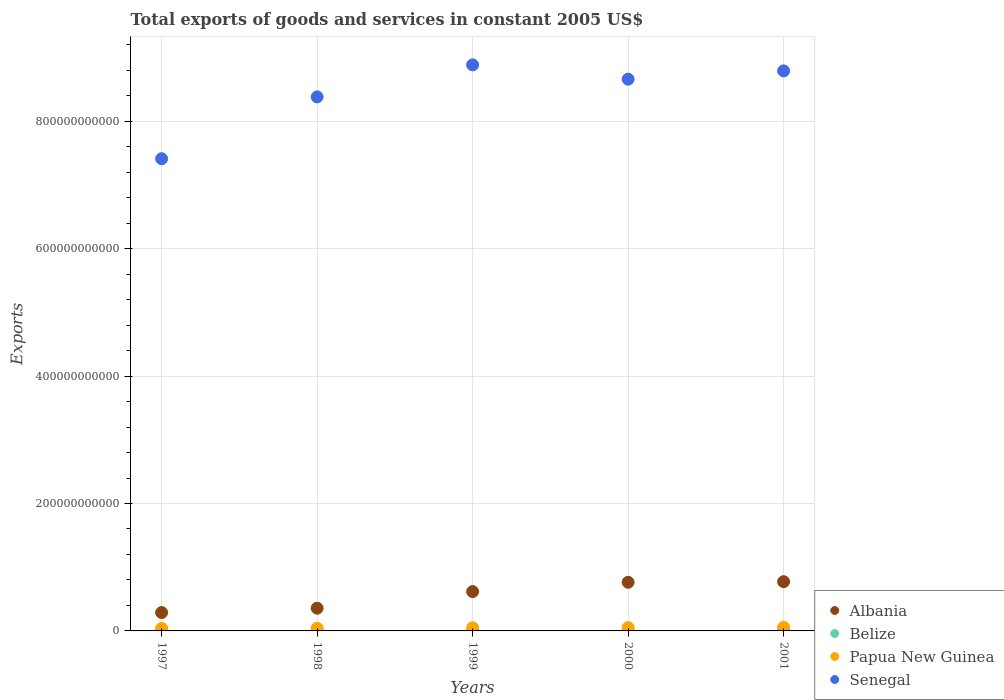What is the total exports of goods and services in Albania in 2000?
Offer a very short reply. 7.63e+1. Across all years, what is the maximum total exports of goods and services in Senegal?
Provide a short and direct response. 8.89e+11. Across all years, what is the minimum total exports of goods and services in Albania?
Ensure brevity in your answer.  2.88e+1. What is the total total exports of goods and services in Belize in the graph?
Your answer should be very brief. 4.02e+09. What is the difference between the total exports of goods and services in Belize in 1997 and that in 2001?
Ensure brevity in your answer.  -2.42e+08. What is the difference between the total exports of goods and services in Senegal in 1997 and the total exports of goods and services in Papua New Guinea in 1999?
Your response must be concise. 7.36e+11. What is the average total exports of goods and services in Belize per year?
Keep it short and to the point. 8.03e+08. In the year 2001, what is the difference between the total exports of goods and services in Papua New Guinea and total exports of goods and services in Belize?
Offer a very short reply. 4.85e+09. What is the ratio of the total exports of goods and services in Senegal in 1997 to that in 1999?
Provide a succinct answer. 0.83. Is the total exports of goods and services in Albania in 1999 less than that in 2000?
Give a very brief answer. Yes. What is the difference between the highest and the second highest total exports of goods and services in Albania?
Your response must be concise. 9.52e+08. What is the difference between the highest and the lowest total exports of goods and services in Senegal?
Provide a short and direct response. 1.47e+11. Is it the case that in every year, the sum of the total exports of goods and services in Albania and total exports of goods and services in Senegal  is greater than the total exports of goods and services in Belize?
Keep it short and to the point. Yes. Does the total exports of goods and services in Belize monotonically increase over the years?
Your answer should be compact. Yes. Is the total exports of goods and services in Belize strictly less than the total exports of goods and services in Senegal over the years?
Provide a succinct answer. Yes. How many dotlines are there?
Ensure brevity in your answer.  4. What is the difference between two consecutive major ticks on the Y-axis?
Make the answer very short. 2.00e+11. Where does the legend appear in the graph?
Your answer should be very brief. Bottom right. What is the title of the graph?
Make the answer very short. Total exports of goods and services in constant 2005 US$. Does "Mexico" appear as one of the legend labels in the graph?
Your answer should be compact. No. What is the label or title of the Y-axis?
Your answer should be very brief. Exports. What is the Exports of Albania in 1997?
Offer a very short reply. 2.88e+1. What is the Exports of Belize in 1997?
Offer a very short reply. 6.83e+08. What is the Exports in Papua New Guinea in 1997?
Your response must be concise. 3.99e+09. What is the Exports in Senegal in 1997?
Provide a succinct answer. 7.41e+11. What is the Exports of Albania in 1998?
Ensure brevity in your answer.  3.57e+1. What is the Exports of Belize in 1998?
Provide a succinct answer. 7.17e+08. What is the Exports of Papua New Guinea in 1998?
Ensure brevity in your answer.  4.22e+09. What is the Exports in Senegal in 1998?
Keep it short and to the point. 8.38e+11. What is the Exports in Albania in 1999?
Offer a very short reply. 6.18e+1. What is the Exports of Belize in 1999?
Your response must be concise. 8.11e+08. What is the Exports of Papua New Guinea in 1999?
Provide a succinct answer. 4.88e+09. What is the Exports in Senegal in 1999?
Offer a terse response. 8.89e+11. What is the Exports of Albania in 2000?
Give a very brief answer. 7.63e+1. What is the Exports of Belize in 2000?
Provide a succinct answer. 8.82e+08. What is the Exports of Papua New Guinea in 2000?
Provide a short and direct response. 5.23e+09. What is the Exports of Senegal in 2000?
Keep it short and to the point. 8.66e+11. What is the Exports in Albania in 2001?
Your response must be concise. 7.73e+1. What is the Exports of Belize in 2001?
Offer a very short reply. 9.25e+08. What is the Exports in Papua New Guinea in 2001?
Offer a very short reply. 5.78e+09. What is the Exports of Senegal in 2001?
Your response must be concise. 8.79e+11. Across all years, what is the maximum Exports in Albania?
Your answer should be compact. 7.73e+1. Across all years, what is the maximum Exports of Belize?
Ensure brevity in your answer.  9.25e+08. Across all years, what is the maximum Exports of Papua New Guinea?
Make the answer very short. 5.78e+09. Across all years, what is the maximum Exports in Senegal?
Your answer should be compact. 8.89e+11. Across all years, what is the minimum Exports of Albania?
Offer a very short reply. 2.88e+1. Across all years, what is the minimum Exports in Belize?
Provide a succinct answer. 6.83e+08. Across all years, what is the minimum Exports in Papua New Guinea?
Offer a very short reply. 3.99e+09. Across all years, what is the minimum Exports of Senegal?
Offer a very short reply. 7.41e+11. What is the total Exports of Albania in the graph?
Offer a terse response. 2.80e+11. What is the total Exports in Belize in the graph?
Make the answer very short. 4.02e+09. What is the total Exports of Papua New Guinea in the graph?
Keep it short and to the point. 2.41e+1. What is the total Exports of Senegal in the graph?
Provide a short and direct response. 4.21e+12. What is the difference between the Exports of Albania in 1997 and that in 1998?
Your answer should be compact. -6.86e+09. What is the difference between the Exports of Belize in 1997 and that in 1998?
Make the answer very short. -3.49e+07. What is the difference between the Exports of Papua New Guinea in 1997 and that in 1998?
Give a very brief answer. -2.25e+08. What is the difference between the Exports of Senegal in 1997 and that in 1998?
Offer a terse response. -9.71e+1. What is the difference between the Exports in Albania in 1997 and that in 1999?
Provide a short and direct response. -3.29e+1. What is the difference between the Exports in Belize in 1997 and that in 1999?
Give a very brief answer. -1.28e+08. What is the difference between the Exports of Papua New Guinea in 1997 and that in 1999?
Offer a terse response. -8.91e+08. What is the difference between the Exports of Senegal in 1997 and that in 1999?
Give a very brief answer. -1.47e+11. What is the difference between the Exports in Albania in 1997 and that in 2000?
Offer a very short reply. -4.75e+1. What is the difference between the Exports of Belize in 1997 and that in 2000?
Provide a succinct answer. -1.99e+08. What is the difference between the Exports in Papua New Guinea in 1997 and that in 2000?
Ensure brevity in your answer.  -1.24e+09. What is the difference between the Exports in Senegal in 1997 and that in 2000?
Ensure brevity in your answer.  -1.25e+11. What is the difference between the Exports of Albania in 1997 and that in 2001?
Your answer should be compact. -4.85e+1. What is the difference between the Exports in Belize in 1997 and that in 2001?
Offer a terse response. -2.42e+08. What is the difference between the Exports in Papua New Guinea in 1997 and that in 2001?
Give a very brief answer. -1.78e+09. What is the difference between the Exports of Senegal in 1997 and that in 2001?
Provide a short and direct response. -1.38e+11. What is the difference between the Exports of Albania in 1998 and that in 1999?
Keep it short and to the point. -2.61e+1. What is the difference between the Exports of Belize in 1998 and that in 1999?
Offer a terse response. -9.31e+07. What is the difference between the Exports of Papua New Guinea in 1998 and that in 1999?
Give a very brief answer. -6.66e+08. What is the difference between the Exports of Senegal in 1998 and that in 1999?
Give a very brief answer. -5.03e+1. What is the difference between the Exports in Albania in 1998 and that in 2000?
Your response must be concise. -4.07e+1. What is the difference between the Exports of Belize in 1998 and that in 2000?
Make the answer very short. -1.64e+08. What is the difference between the Exports in Papua New Guinea in 1998 and that in 2000?
Make the answer very short. -1.01e+09. What is the difference between the Exports in Senegal in 1998 and that in 2000?
Provide a short and direct response. -2.78e+1. What is the difference between the Exports of Albania in 1998 and that in 2001?
Make the answer very short. -4.16e+1. What is the difference between the Exports in Belize in 1998 and that in 2001?
Keep it short and to the point. -2.07e+08. What is the difference between the Exports of Papua New Guinea in 1998 and that in 2001?
Your response must be concise. -1.56e+09. What is the difference between the Exports in Senegal in 1998 and that in 2001?
Offer a terse response. -4.08e+1. What is the difference between the Exports in Albania in 1999 and that in 2000?
Give a very brief answer. -1.46e+1. What is the difference between the Exports of Belize in 1999 and that in 2000?
Ensure brevity in your answer.  -7.09e+07. What is the difference between the Exports in Papua New Guinea in 1999 and that in 2000?
Offer a terse response. -3.46e+08. What is the difference between the Exports in Senegal in 1999 and that in 2000?
Make the answer very short. 2.25e+1. What is the difference between the Exports of Albania in 1999 and that in 2001?
Offer a terse response. -1.55e+1. What is the difference between the Exports in Belize in 1999 and that in 2001?
Give a very brief answer. -1.14e+08. What is the difference between the Exports in Papua New Guinea in 1999 and that in 2001?
Give a very brief answer. -8.92e+08. What is the difference between the Exports in Senegal in 1999 and that in 2001?
Give a very brief answer. 9.46e+09. What is the difference between the Exports of Albania in 2000 and that in 2001?
Make the answer very short. -9.52e+08. What is the difference between the Exports in Belize in 2000 and that in 2001?
Your answer should be compact. -4.34e+07. What is the difference between the Exports in Papua New Guinea in 2000 and that in 2001?
Provide a succinct answer. -5.46e+08. What is the difference between the Exports of Senegal in 2000 and that in 2001?
Make the answer very short. -1.30e+1. What is the difference between the Exports in Albania in 1997 and the Exports in Belize in 1998?
Provide a succinct answer. 2.81e+1. What is the difference between the Exports of Albania in 1997 and the Exports of Papua New Guinea in 1998?
Give a very brief answer. 2.46e+1. What is the difference between the Exports in Albania in 1997 and the Exports in Senegal in 1998?
Give a very brief answer. -8.10e+11. What is the difference between the Exports in Belize in 1997 and the Exports in Papua New Guinea in 1998?
Your answer should be very brief. -3.53e+09. What is the difference between the Exports in Belize in 1997 and the Exports in Senegal in 1998?
Provide a short and direct response. -8.38e+11. What is the difference between the Exports in Papua New Guinea in 1997 and the Exports in Senegal in 1998?
Your answer should be very brief. -8.34e+11. What is the difference between the Exports in Albania in 1997 and the Exports in Belize in 1999?
Ensure brevity in your answer.  2.80e+1. What is the difference between the Exports in Albania in 1997 and the Exports in Papua New Guinea in 1999?
Your answer should be compact. 2.39e+1. What is the difference between the Exports in Albania in 1997 and the Exports in Senegal in 1999?
Your answer should be compact. -8.60e+11. What is the difference between the Exports in Belize in 1997 and the Exports in Papua New Guinea in 1999?
Your answer should be very brief. -4.20e+09. What is the difference between the Exports of Belize in 1997 and the Exports of Senegal in 1999?
Offer a very short reply. -8.88e+11. What is the difference between the Exports of Papua New Guinea in 1997 and the Exports of Senegal in 1999?
Your answer should be very brief. -8.85e+11. What is the difference between the Exports in Albania in 1997 and the Exports in Belize in 2000?
Provide a succinct answer. 2.79e+1. What is the difference between the Exports in Albania in 1997 and the Exports in Papua New Guinea in 2000?
Your response must be concise. 2.36e+1. What is the difference between the Exports of Albania in 1997 and the Exports of Senegal in 2000?
Offer a very short reply. -8.37e+11. What is the difference between the Exports of Belize in 1997 and the Exports of Papua New Guinea in 2000?
Provide a succinct answer. -4.55e+09. What is the difference between the Exports of Belize in 1997 and the Exports of Senegal in 2000?
Offer a terse response. -8.65e+11. What is the difference between the Exports in Papua New Guinea in 1997 and the Exports in Senegal in 2000?
Provide a short and direct response. -8.62e+11. What is the difference between the Exports of Albania in 1997 and the Exports of Belize in 2001?
Your response must be concise. 2.79e+1. What is the difference between the Exports of Albania in 1997 and the Exports of Papua New Guinea in 2001?
Your answer should be very brief. 2.30e+1. What is the difference between the Exports in Albania in 1997 and the Exports in Senegal in 2001?
Your answer should be very brief. -8.50e+11. What is the difference between the Exports of Belize in 1997 and the Exports of Papua New Guinea in 2001?
Provide a short and direct response. -5.09e+09. What is the difference between the Exports of Belize in 1997 and the Exports of Senegal in 2001?
Your answer should be very brief. -8.78e+11. What is the difference between the Exports in Papua New Guinea in 1997 and the Exports in Senegal in 2001?
Ensure brevity in your answer.  -8.75e+11. What is the difference between the Exports in Albania in 1998 and the Exports in Belize in 1999?
Give a very brief answer. 3.49e+1. What is the difference between the Exports in Albania in 1998 and the Exports in Papua New Guinea in 1999?
Your answer should be compact. 3.08e+1. What is the difference between the Exports in Albania in 1998 and the Exports in Senegal in 1999?
Provide a short and direct response. -8.53e+11. What is the difference between the Exports of Belize in 1998 and the Exports of Papua New Guinea in 1999?
Make the answer very short. -4.17e+09. What is the difference between the Exports in Belize in 1998 and the Exports in Senegal in 1999?
Make the answer very short. -8.88e+11. What is the difference between the Exports in Papua New Guinea in 1998 and the Exports in Senegal in 1999?
Your response must be concise. -8.84e+11. What is the difference between the Exports in Albania in 1998 and the Exports in Belize in 2000?
Offer a very short reply. 3.48e+1. What is the difference between the Exports of Albania in 1998 and the Exports of Papua New Guinea in 2000?
Keep it short and to the point. 3.05e+1. What is the difference between the Exports in Albania in 1998 and the Exports in Senegal in 2000?
Your response must be concise. -8.30e+11. What is the difference between the Exports of Belize in 1998 and the Exports of Papua New Guinea in 2000?
Provide a succinct answer. -4.51e+09. What is the difference between the Exports of Belize in 1998 and the Exports of Senegal in 2000?
Your answer should be very brief. -8.65e+11. What is the difference between the Exports in Papua New Guinea in 1998 and the Exports in Senegal in 2000?
Provide a short and direct response. -8.62e+11. What is the difference between the Exports in Albania in 1998 and the Exports in Belize in 2001?
Offer a very short reply. 3.48e+1. What is the difference between the Exports in Albania in 1998 and the Exports in Papua New Guinea in 2001?
Offer a very short reply. 2.99e+1. What is the difference between the Exports in Albania in 1998 and the Exports in Senegal in 2001?
Offer a very short reply. -8.43e+11. What is the difference between the Exports in Belize in 1998 and the Exports in Papua New Guinea in 2001?
Provide a short and direct response. -5.06e+09. What is the difference between the Exports of Belize in 1998 and the Exports of Senegal in 2001?
Offer a very short reply. -8.78e+11. What is the difference between the Exports of Papua New Guinea in 1998 and the Exports of Senegal in 2001?
Your response must be concise. -8.75e+11. What is the difference between the Exports of Albania in 1999 and the Exports of Belize in 2000?
Offer a terse response. 6.09e+1. What is the difference between the Exports in Albania in 1999 and the Exports in Papua New Guinea in 2000?
Offer a terse response. 5.65e+1. What is the difference between the Exports of Albania in 1999 and the Exports of Senegal in 2000?
Offer a very short reply. -8.04e+11. What is the difference between the Exports of Belize in 1999 and the Exports of Papua New Guinea in 2000?
Provide a short and direct response. -4.42e+09. What is the difference between the Exports in Belize in 1999 and the Exports in Senegal in 2000?
Provide a succinct answer. -8.65e+11. What is the difference between the Exports in Papua New Guinea in 1999 and the Exports in Senegal in 2000?
Provide a short and direct response. -8.61e+11. What is the difference between the Exports of Albania in 1999 and the Exports of Belize in 2001?
Make the answer very short. 6.08e+1. What is the difference between the Exports of Albania in 1999 and the Exports of Papua New Guinea in 2001?
Offer a terse response. 5.60e+1. What is the difference between the Exports in Albania in 1999 and the Exports in Senegal in 2001?
Your answer should be compact. -8.17e+11. What is the difference between the Exports in Belize in 1999 and the Exports in Papua New Guinea in 2001?
Make the answer very short. -4.96e+09. What is the difference between the Exports of Belize in 1999 and the Exports of Senegal in 2001?
Ensure brevity in your answer.  -8.78e+11. What is the difference between the Exports in Papua New Guinea in 1999 and the Exports in Senegal in 2001?
Provide a short and direct response. -8.74e+11. What is the difference between the Exports in Albania in 2000 and the Exports in Belize in 2001?
Give a very brief answer. 7.54e+1. What is the difference between the Exports of Albania in 2000 and the Exports of Papua New Guinea in 2001?
Your response must be concise. 7.06e+1. What is the difference between the Exports in Albania in 2000 and the Exports in Senegal in 2001?
Ensure brevity in your answer.  -8.03e+11. What is the difference between the Exports in Belize in 2000 and the Exports in Papua New Guinea in 2001?
Your answer should be compact. -4.89e+09. What is the difference between the Exports in Belize in 2000 and the Exports in Senegal in 2001?
Provide a succinct answer. -8.78e+11. What is the difference between the Exports in Papua New Guinea in 2000 and the Exports in Senegal in 2001?
Offer a very short reply. -8.74e+11. What is the average Exports of Albania per year?
Offer a very short reply. 5.60e+1. What is the average Exports of Belize per year?
Provide a short and direct response. 8.03e+08. What is the average Exports in Papua New Guinea per year?
Your answer should be compact. 4.82e+09. What is the average Exports of Senegal per year?
Offer a terse response. 8.43e+11. In the year 1997, what is the difference between the Exports in Albania and Exports in Belize?
Your answer should be very brief. 2.81e+1. In the year 1997, what is the difference between the Exports of Albania and Exports of Papua New Guinea?
Give a very brief answer. 2.48e+1. In the year 1997, what is the difference between the Exports of Albania and Exports of Senegal?
Give a very brief answer. -7.12e+11. In the year 1997, what is the difference between the Exports in Belize and Exports in Papua New Guinea?
Offer a very short reply. -3.31e+09. In the year 1997, what is the difference between the Exports of Belize and Exports of Senegal?
Provide a short and direct response. -7.41e+11. In the year 1997, what is the difference between the Exports in Papua New Guinea and Exports in Senegal?
Ensure brevity in your answer.  -7.37e+11. In the year 1998, what is the difference between the Exports in Albania and Exports in Belize?
Provide a short and direct response. 3.50e+1. In the year 1998, what is the difference between the Exports of Albania and Exports of Papua New Guinea?
Your answer should be very brief. 3.15e+1. In the year 1998, what is the difference between the Exports of Albania and Exports of Senegal?
Keep it short and to the point. -8.03e+11. In the year 1998, what is the difference between the Exports in Belize and Exports in Papua New Guinea?
Provide a short and direct response. -3.50e+09. In the year 1998, what is the difference between the Exports of Belize and Exports of Senegal?
Ensure brevity in your answer.  -8.38e+11. In the year 1998, what is the difference between the Exports of Papua New Guinea and Exports of Senegal?
Give a very brief answer. -8.34e+11. In the year 1999, what is the difference between the Exports of Albania and Exports of Belize?
Keep it short and to the point. 6.09e+1. In the year 1999, what is the difference between the Exports in Albania and Exports in Papua New Guinea?
Make the answer very short. 5.69e+1. In the year 1999, what is the difference between the Exports of Albania and Exports of Senegal?
Ensure brevity in your answer.  -8.27e+11. In the year 1999, what is the difference between the Exports in Belize and Exports in Papua New Guinea?
Offer a terse response. -4.07e+09. In the year 1999, what is the difference between the Exports of Belize and Exports of Senegal?
Provide a short and direct response. -8.88e+11. In the year 1999, what is the difference between the Exports of Papua New Guinea and Exports of Senegal?
Provide a succinct answer. -8.84e+11. In the year 2000, what is the difference between the Exports in Albania and Exports in Belize?
Give a very brief answer. 7.55e+1. In the year 2000, what is the difference between the Exports of Albania and Exports of Papua New Guinea?
Your answer should be very brief. 7.11e+1. In the year 2000, what is the difference between the Exports of Albania and Exports of Senegal?
Your answer should be very brief. -7.90e+11. In the year 2000, what is the difference between the Exports of Belize and Exports of Papua New Guinea?
Provide a short and direct response. -4.35e+09. In the year 2000, what is the difference between the Exports of Belize and Exports of Senegal?
Your answer should be very brief. -8.65e+11. In the year 2000, what is the difference between the Exports in Papua New Guinea and Exports in Senegal?
Provide a short and direct response. -8.61e+11. In the year 2001, what is the difference between the Exports of Albania and Exports of Belize?
Offer a terse response. 7.64e+1. In the year 2001, what is the difference between the Exports of Albania and Exports of Papua New Guinea?
Make the answer very short. 7.15e+1. In the year 2001, what is the difference between the Exports in Albania and Exports in Senegal?
Provide a short and direct response. -8.02e+11. In the year 2001, what is the difference between the Exports in Belize and Exports in Papua New Guinea?
Provide a short and direct response. -4.85e+09. In the year 2001, what is the difference between the Exports of Belize and Exports of Senegal?
Your response must be concise. -8.78e+11. In the year 2001, what is the difference between the Exports of Papua New Guinea and Exports of Senegal?
Keep it short and to the point. -8.73e+11. What is the ratio of the Exports in Albania in 1997 to that in 1998?
Provide a short and direct response. 0.81. What is the ratio of the Exports in Belize in 1997 to that in 1998?
Offer a very short reply. 0.95. What is the ratio of the Exports of Papua New Guinea in 1997 to that in 1998?
Provide a succinct answer. 0.95. What is the ratio of the Exports in Senegal in 1997 to that in 1998?
Provide a succinct answer. 0.88. What is the ratio of the Exports in Albania in 1997 to that in 1999?
Make the answer very short. 0.47. What is the ratio of the Exports of Belize in 1997 to that in 1999?
Offer a terse response. 0.84. What is the ratio of the Exports in Papua New Guinea in 1997 to that in 1999?
Make the answer very short. 0.82. What is the ratio of the Exports of Senegal in 1997 to that in 1999?
Provide a succinct answer. 0.83. What is the ratio of the Exports in Albania in 1997 to that in 2000?
Offer a very short reply. 0.38. What is the ratio of the Exports of Belize in 1997 to that in 2000?
Provide a succinct answer. 0.77. What is the ratio of the Exports of Papua New Guinea in 1997 to that in 2000?
Keep it short and to the point. 0.76. What is the ratio of the Exports in Senegal in 1997 to that in 2000?
Keep it short and to the point. 0.86. What is the ratio of the Exports of Albania in 1997 to that in 2001?
Your response must be concise. 0.37. What is the ratio of the Exports of Belize in 1997 to that in 2001?
Ensure brevity in your answer.  0.74. What is the ratio of the Exports in Papua New Guinea in 1997 to that in 2001?
Offer a very short reply. 0.69. What is the ratio of the Exports in Senegal in 1997 to that in 2001?
Your response must be concise. 0.84. What is the ratio of the Exports in Albania in 1998 to that in 1999?
Your response must be concise. 0.58. What is the ratio of the Exports in Belize in 1998 to that in 1999?
Your answer should be very brief. 0.89. What is the ratio of the Exports of Papua New Guinea in 1998 to that in 1999?
Provide a succinct answer. 0.86. What is the ratio of the Exports of Senegal in 1998 to that in 1999?
Offer a terse response. 0.94. What is the ratio of the Exports in Albania in 1998 to that in 2000?
Your response must be concise. 0.47. What is the ratio of the Exports in Belize in 1998 to that in 2000?
Give a very brief answer. 0.81. What is the ratio of the Exports in Papua New Guinea in 1998 to that in 2000?
Your response must be concise. 0.81. What is the ratio of the Exports of Senegal in 1998 to that in 2000?
Your response must be concise. 0.97. What is the ratio of the Exports in Albania in 1998 to that in 2001?
Offer a terse response. 0.46. What is the ratio of the Exports in Belize in 1998 to that in 2001?
Provide a succinct answer. 0.78. What is the ratio of the Exports in Papua New Guinea in 1998 to that in 2001?
Offer a very short reply. 0.73. What is the ratio of the Exports in Senegal in 1998 to that in 2001?
Your response must be concise. 0.95. What is the ratio of the Exports of Albania in 1999 to that in 2000?
Offer a terse response. 0.81. What is the ratio of the Exports in Belize in 1999 to that in 2000?
Provide a succinct answer. 0.92. What is the ratio of the Exports of Papua New Guinea in 1999 to that in 2000?
Your response must be concise. 0.93. What is the ratio of the Exports of Senegal in 1999 to that in 2000?
Your response must be concise. 1.03. What is the ratio of the Exports in Albania in 1999 to that in 2001?
Your response must be concise. 0.8. What is the ratio of the Exports of Belize in 1999 to that in 2001?
Your answer should be compact. 0.88. What is the ratio of the Exports in Papua New Guinea in 1999 to that in 2001?
Make the answer very short. 0.85. What is the ratio of the Exports in Senegal in 1999 to that in 2001?
Give a very brief answer. 1.01. What is the ratio of the Exports in Albania in 2000 to that in 2001?
Offer a terse response. 0.99. What is the ratio of the Exports of Belize in 2000 to that in 2001?
Your answer should be very brief. 0.95. What is the ratio of the Exports in Papua New Guinea in 2000 to that in 2001?
Your answer should be compact. 0.91. What is the ratio of the Exports in Senegal in 2000 to that in 2001?
Your response must be concise. 0.99. What is the difference between the highest and the second highest Exports in Albania?
Offer a very short reply. 9.52e+08. What is the difference between the highest and the second highest Exports in Belize?
Offer a terse response. 4.34e+07. What is the difference between the highest and the second highest Exports in Papua New Guinea?
Offer a very short reply. 5.46e+08. What is the difference between the highest and the second highest Exports in Senegal?
Offer a very short reply. 9.46e+09. What is the difference between the highest and the lowest Exports in Albania?
Your answer should be compact. 4.85e+1. What is the difference between the highest and the lowest Exports in Belize?
Give a very brief answer. 2.42e+08. What is the difference between the highest and the lowest Exports of Papua New Guinea?
Keep it short and to the point. 1.78e+09. What is the difference between the highest and the lowest Exports in Senegal?
Provide a succinct answer. 1.47e+11. 